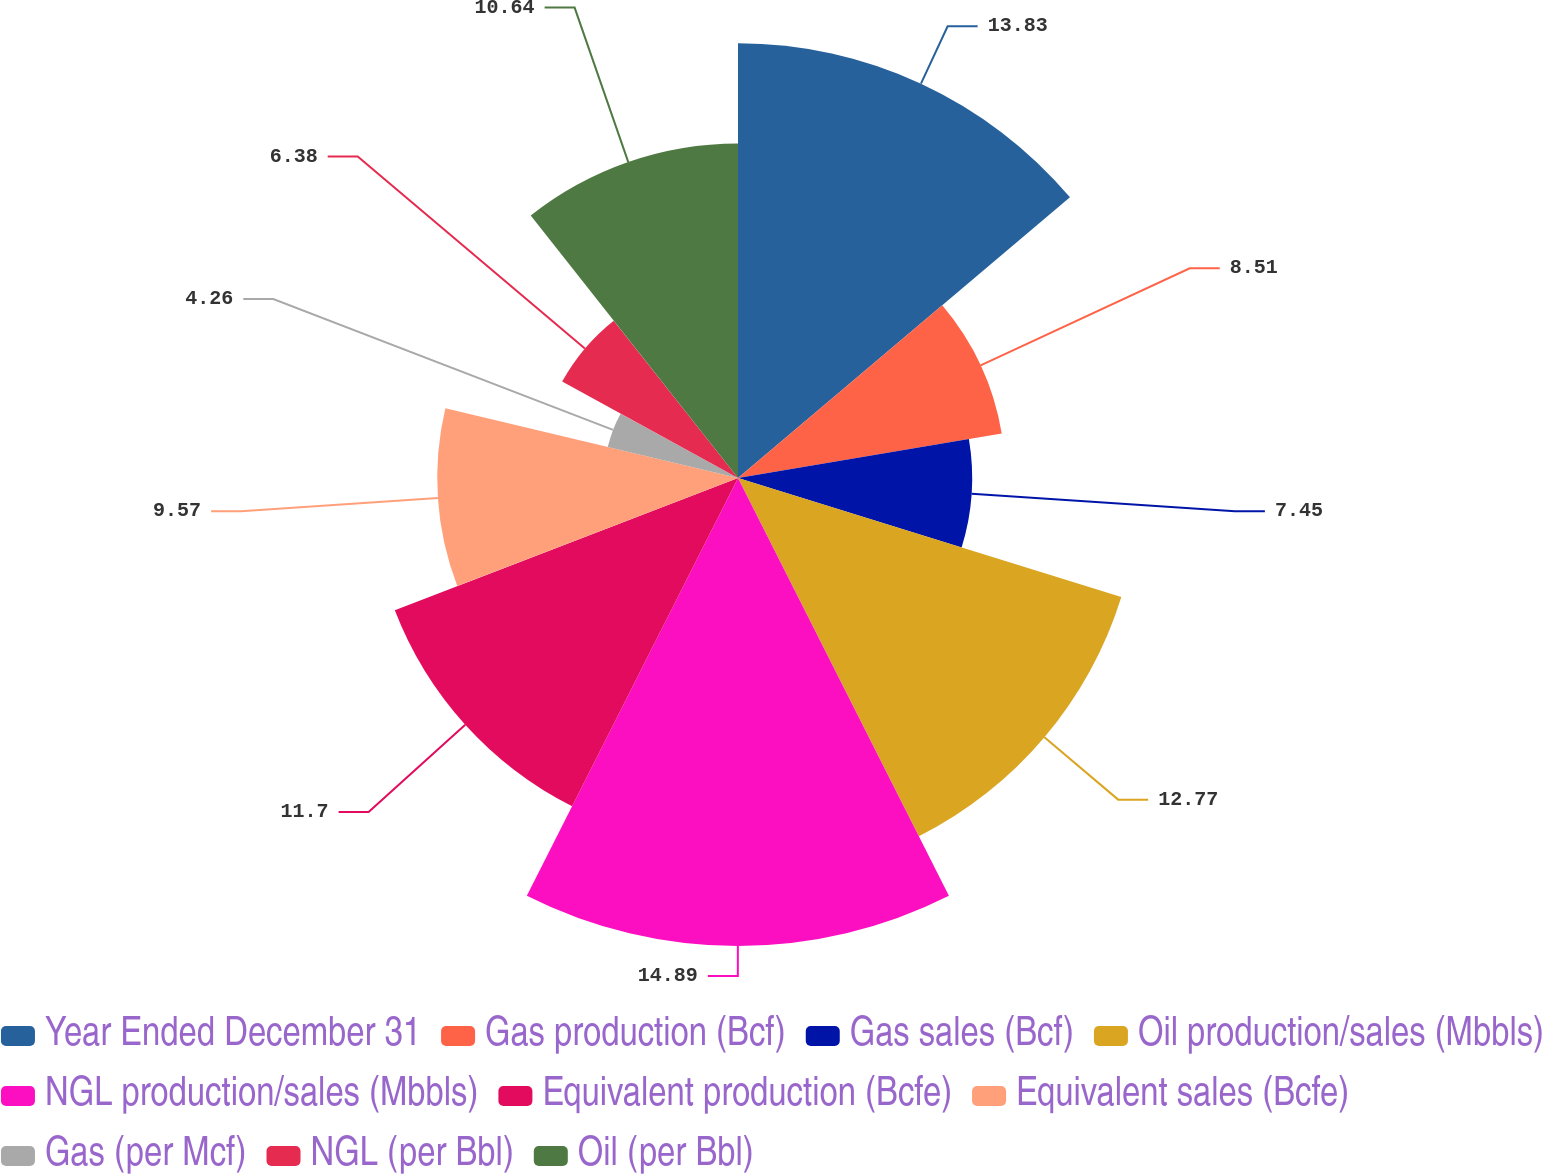Convert chart to OTSL. <chart><loc_0><loc_0><loc_500><loc_500><pie_chart><fcel>Year Ended December 31<fcel>Gas production (Bcf)<fcel>Gas sales (Bcf)<fcel>Oil production/sales (Mbbls)<fcel>NGL production/sales (Mbbls)<fcel>Equivalent production (Bcfe)<fcel>Equivalent sales (Bcfe)<fcel>Gas (per Mcf)<fcel>NGL (per Bbl)<fcel>Oil (per Bbl)<nl><fcel>13.83%<fcel>8.51%<fcel>7.45%<fcel>12.77%<fcel>14.89%<fcel>11.7%<fcel>9.57%<fcel>4.26%<fcel>6.38%<fcel>10.64%<nl></chart> 